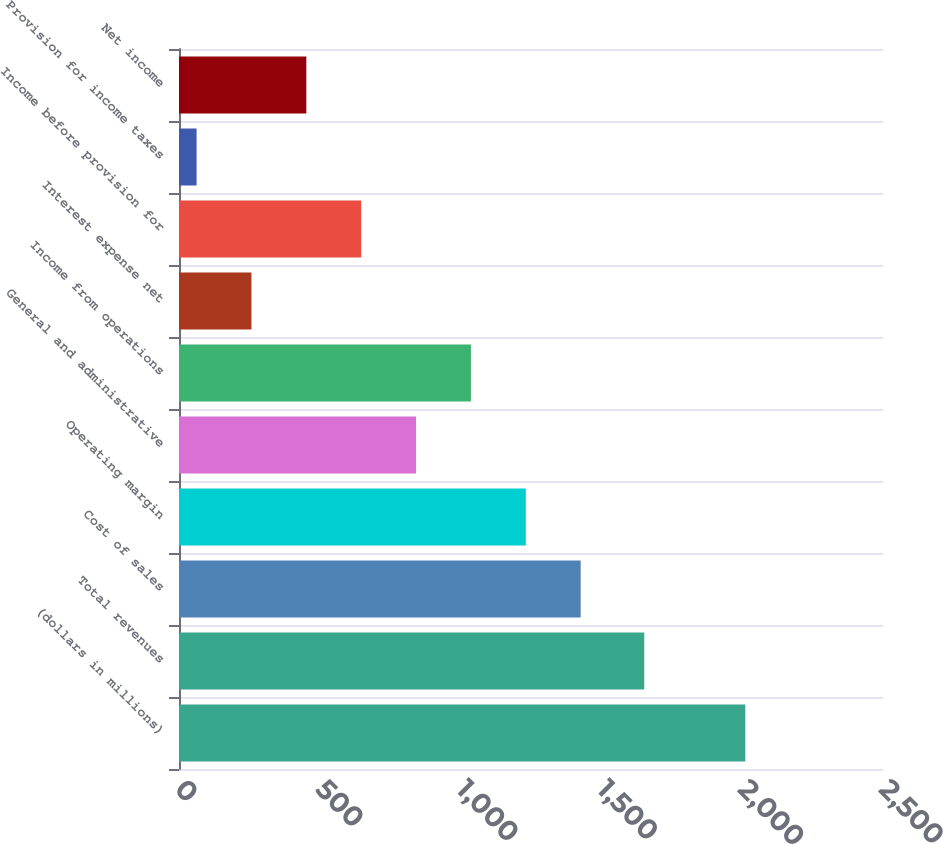Convert chart to OTSL. <chart><loc_0><loc_0><loc_500><loc_500><bar_chart><fcel>(dollars in millions)<fcel>Total revenues<fcel>Cost of sales<fcel>Operating margin<fcel>General and administrative<fcel>Income from operations<fcel>Interest expense net<fcel>Income before provision for<fcel>Provision for income taxes<fcel>Net income<nl><fcel>2011<fcel>1652.2<fcel>1426.42<fcel>1231.56<fcel>841.84<fcel>1036.7<fcel>257.26<fcel>646.98<fcel>62.4<fcel>452.12<nl></chart> 